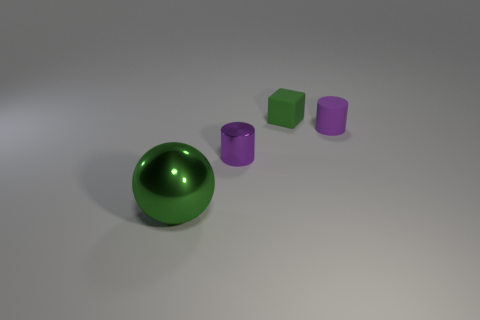Do the cylinder that is behind the small shiny cylinder and the large object have the same color?
Your answer should be compact. No. What number of other small purple rubber objects have the same shape as the purple rubber object?
Provide a short and direct response. 0. Is the number of shiny spheres that are in front of the green ball the same as the number of red rubber objects?
Provide a succinct answer. Yes. What color is the cylinder that is the same size as the purple shiny object?
Ensure brevity in your answer.  Purple. Are there any big green metallic things that have the same shape as the purple shiny object?
Your response must be concise. No. What material is the cylinder that is to the left of the rubber thing that is to the right of the green object that is on the right side of the tiny metallic thing made of?
Offer a terse response. Metal. How many other objects are the same size as the green metal ball?
Your response must be concise. 0. The small metallic cylinder has what color?
Offer a terse response. Purple. How many metal objects are cylinders or big green objects?
Offer a very short reply. 2. Are there any other things that have the same material as the big green sphere?
Keep it short and to the point. Yes. 